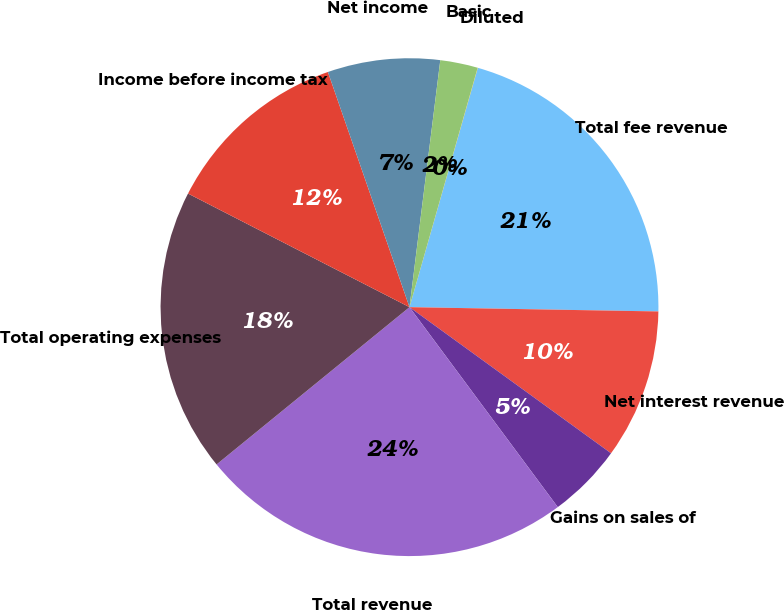Convert chart. <chart><loc_0><loc_0><loc_500><loc_500><pie_chart><fcel>Total fee revenue<fcel>Net interest revenue<fcel>Gains on sales of<fcel>Total revenue<fcel>Total operating expenses<fcel>Income before income tax<fcel>Net income<fcel>Basic<fcel>Diluted<nl><fcel>20.85%<fcel>9.71%<fcel>4.86%<fcel>24.27%<fcel>18.43%<fcel>12.14%<fcel>7.29%<fcel>2.44%<fcel>0.01%<nl></chart> 